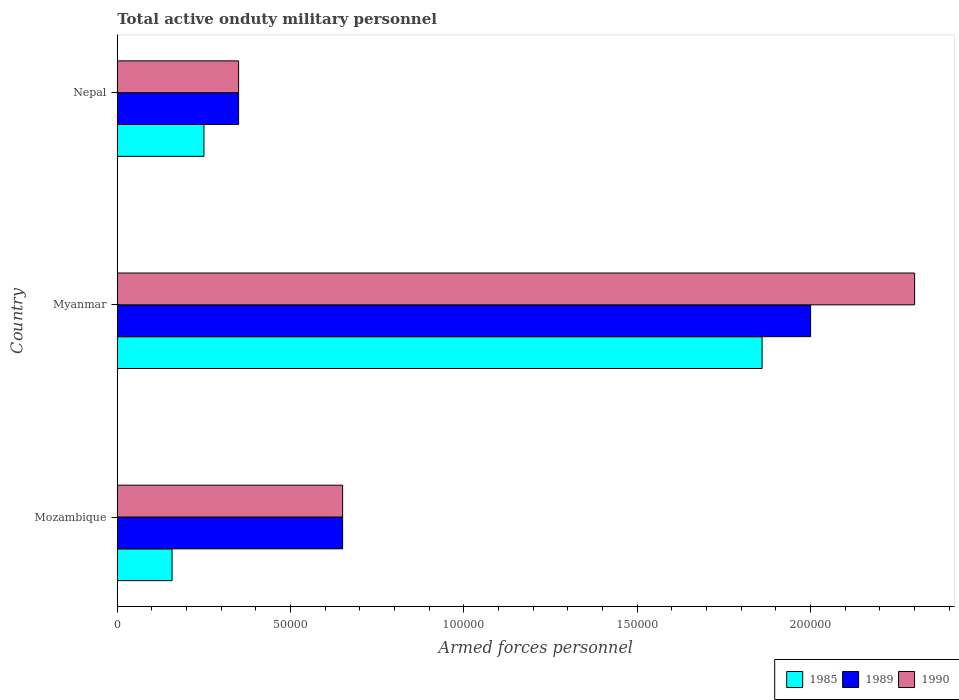How many groups of bars are there?
Keep it short and to the point. 3. Are the number of bars per tick equal to the number of legend labels?
Ensure brevity in your answer.  Yes. What is the label of the 1st group of bars from the top?
Your response must be concise. Nepal. What is the number of armed forces personnel in 1990 in Mozambique?
Your answer should be very brief. 6.50e+04. Across all countries, what is the maximum number of armed forces personnel in 1985?
Make the answer very short. 1.86e+05. Across all countries, what is the minimum number of armed forces personnel in 1990?
Make the answer very short. 3.50e+04. In which country was the number of armed forces personnel in 1990 maximum?
Your response must be concise. Myanmar. In which country was the number of armed forces personnel in 1985 minimum?
Give a very brief answer. Mozambique. What is the total number of armed forces personnel in 1989 in the graph?
Provide a short and direct response. 3.00e+05. What is the difference between the number of armed forces personnel in 1985 in Mozambique and that in Nepal?
Your response must be concise. -9200. What is the difference between the number of armed forces personnel in 1989 in Myanmar and the number of armed forces personnel in 1985 in Mozambique?
Keep it short and to the point. 1.84e+05. What is the average number of armed forces personnel in 1989 per country?
Provide a succinct answer. 1.00e+05. What is the difference between the number of armed forces personnel in 1985 and number of armed forces personnel in 1989 in Mozambique?
Keep it short and to the point. -4.92e+04. In how many countries, is the number of armed forces personnel in 1989 greater than 70000 ?
Offer a terse response. 1. What is the ratio of the number of armed forces personnel in 1990 in Mozambique to that in Nepal?
Make the answer very short. 1.86. Is the number of armed forces personnel in 1989 in Myanmar less than that in Nepal?
Keep it short and to the point. No. What is the difference between the highest and the second highest number of armed forces personnel in 1985?
Keep it short and to the point. 1.61e+05. What is the difference between the highest and the lowest number of armed forces personnel in 1985?
Your response must be concise. 1.70e+05. What does the 2nd bar from the bottom in Mozambique represents?
Give a very brief answer. 1989. Is it the case that in every country, the sum of the number of armed forces personnel in 1989 and number of armed forces personnel in 1985 is greater than the number of armed forces personnel in 1990?
Make the answer very short. Yes. How many bars are there?
Provide a succinct answer. 9. What is the title of the graph?
Offer a very short reply. Total active onduty military personnel. Does "1961" appear as one of the legend labels in the graph?
Your answer should be very brief. No. What is the label or title of the X-axis?
Provide a succinct answer. Armed forces personnel. What is the Armed forces personnel of 1985 in Mozambique?
Your response must be concise. 1.58e+04. What is the Armed forces personnel of 1989 in Mozambique?
Make the answer very short. 6.50e+04. What is the Armed forces personnel of 1990 in Mozambique?
Ensure brevity in your answer.  6.50e+04. What is the Armed forces personnel of 1985 in Myanmar?
Your response must be concise. 1.86e+05. What is the Armed forces personnel in 1985 in Nepal?
Your answer should be compact. 2.50e+04. What is the Armed forces personnel in 1989 in Nepal?
Keep it short and to the point. 3.50e+04. What is the Armed forces personnel of 1990 in Nepal?
Your answer should be compact. 3.50e+04. Across all countries, what is the maximum Armed forces personnel in 1985?
Your answer should be very brief. 1.86e+05. Across all countries, what is the maximum Armed forces personnel in 1989?
Your answer should be compact. 2.00e+05. Across all countries, what is the minimum Armed forces personnel of 1985?
Your response must be concise. 1.58e+04. Across all countries, what is the minimum Armed forces personnel of 1989?
Keep it short and to the point. 3.50e+04. Across all countries, what is the minimum Armed forces personnel of 1990?
Ensure brevity in your answer.  3.50e+04. What is the total Armed forces personnel in 1985 in the graph?
Provide a succinct answer. 2.27e+05. What is the total Armed forces personnel in 1989 in the graph?
Offer a terse response. 3.00e+05. What is the total Armed forces personnel in 1990 in the graph?
Provide a short and direct response. 3.30e+05. What is the difference between the Armed forces personnel in 1985 in Mozambique and that in Myanmar?
Your response must be concise. -1.70e+05. What is the difference between the Armed forces personnel of 1989 in Mozambique and that in Myanmar?
Your response must be concise. -1.35e+05. What is the difference between the Armed forces personnel of 1990 in Mozambique and that in Myanmar?
Make the answer very short. -1.65e+05. What is the difference between the Armed forces personnel in 1985 in Mozambique and that in Nepal?
Provide a succinct answer. -9200. What is the difference between the Armed forces personnel in 1990 in Mozambique and that in Nepal?
Your response must be concise. 3.00e+04. What is the difference between the Armed forces personnel of 1985 in Myanmar and that in Nepal?
Make the answer very short. 1.61e+05. What is the difference between the Armed forces personnel in 1989 in Myanmar and that in Nepal?
Your answer should be compact. 1.65e+05. What is the difference between the Armed forces personnel in 1990 in Myanmar and that in Nepal?
Offer a very short reply. 1.95e+05. What is the difference between the Armed forces personnel of 1985 in Mozambique and the Armed forces personnel of 1989 in Myanmar?
Provide a succinct answer. -1.84e+05. What is the difference between the Armed forces personnel of 1985 in Mozambique and the Armed forces personnel of 1990 in Myanmar?
Offer a very short reply. -2.14e+05. What is the difference between the Armed forces personnel of 1989 in Mozambique and the Armed forces personnel of 1990 in Myanmar?
Make the answer very short. -1.65e+05. What is the difference between the Armed forces personnel of 1985 in Mozambique and the Armed forces personnel of 1989 in Nepal?
Keep it short and to the point. -1.92e+04. What is the difference between the Armed forces personnel of 1985 in Mozambique and the Armed forces personnel of 1990 in Nepal?
Make the answer very short. -1.92e+04. What is the difference between the Armed forces personnel of 1989 in Mozambique and the Armed forces personnel of 1990 in Nepal?
Your answer should be compact. 3.00e+04. What is the difference between the Armed forces personnel in 1985 in Myanmar and the Armed forces personnel in 1989 in Nepal?
Offer a very short reply. 1.51e+05. What is the difference between the Armed forces personnel in 1985 in Myanmar and the Armed forces personnel in 1990 in Nepal?
Make the answer very short. 1.51e+05. What is the difference between the Armed forces personnel of 1989 in Myanmar and the Armed forces personnel of 1990 in Nepal?
Keep it short and to the point. 1.65e+05. What is the average Armed forces personnel of 1985 per country?
Your response must be concise. 7.56e+04. What is the average Armed forces personnel in 1990 per country?
Offer a terse response. 1.10e+05. What is the difference between the Armed forces personnel of 1985 and Armed forces personnel of 1989 in Mozambique?
Ensure brevity in your answer.  -4.92e+04. What is the difference between the Armed forces personnel in 1985 and Armed forces personnel in 1990 in Mozambique?
Give a very brief answer. -4.92e+04. What is the difference between the Armed forces personnel of 1985 and Armed forces personnel of 1989 in Myanmar?
Your response must be concise. -1.40e+04. What is the difference between the Armed forces personnel of 1985 and Armed forces personnel of 1990 in Myanmar?
Your answer should be very brief. -4.40e+04. What is the difference between the Armed forces personnel in 1989 and Armed forces personnel in 1990 in Myanmar?
Keep it short and to the point. -3.00e+04. What is the difference between the Armed forces personnel of 1985 and Armed forces personnel of 1989 in Nepal?
Ensure brevity in your answer.  -10000. What is the difference between the Armed forces personnel of 1985 and Armed forces personnel of 1990 in Nepal?
Your answer should be compact. -10000. What is the difference between the Armed forces personnel of 1989 and Armed forces personnel of 1990 in Nepal?
Provide a short and direct response. 0. What is the ratio of the Armed forces personnel of 1985 in Mozambique to that in Myanmar?
Your answer should be very brief. 0.08. What is the ratio of the Armed forces personnel of 1989 in Mozambique to that in Myanmar?
Provide a short and direct response. 0.33. What is the ratio of the Armed forces personnel of 1990 in Mozambique to that in Myanmar?
Offer a terse response. 0.28. What is the ratio of the Armed forces personnel in 1985 in Mozambique to that in Nepal?
Keep it short and to the point. 0.63. What is the ratio of the Armed forces personnel of 1989 in Mozambique to that in Nepal?
Ensure brevity in your answer.  1.86. What is the ratio of the Armed forces personnel of 1990 in Mozambique to that in Nepal?
Provide a succinct answer. 1.86. What is the ratio of the Armed forces personnel of 1985 in Myanmar to that in Nepal?
Provide a short and direct response. 7.44. What is the ratio of the Armed forces personnel in 1989 in Myanmar to that in Nepal?
Provide a short and direct response. 5.71. What is the ratio of the Armed forces personnel in 1990 in Myanmar to that in Nepal?
Keep it short and to the point. 6.57. What is the difference between the highest and the second highest Armed forces personnel in 1985?
Provide a succinct answer. 1.61e+05. What is the difference between the highest and the second highest Armed forces personnel in 1989?
Provide a short and direct response. 1.35e+05. What is the difference between the highest and the second highest Armed forces personnel in 1990?
Offer a terse response. 1.65e+05. What is the difference between the highest and the lowest Armed forces personnel of 1985?
Provide a succinct answer. 1.70e+05. What is the difference between the highest and the lowest Armed forces personnel in 1989?
Your answer should be very brief. 1.65e+05. What is the difference between the highest and the lowest Armed forces personnel in 1990?
Your answer should be compact. 1.95e+05. 